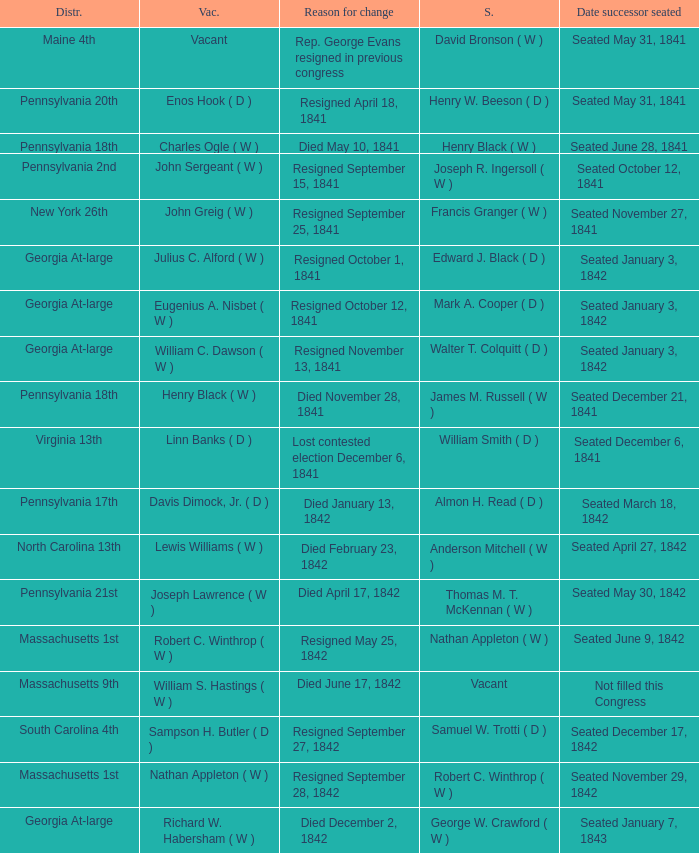Name the date successor seated for pennsylvania 17th Seated March 18, 1842. 